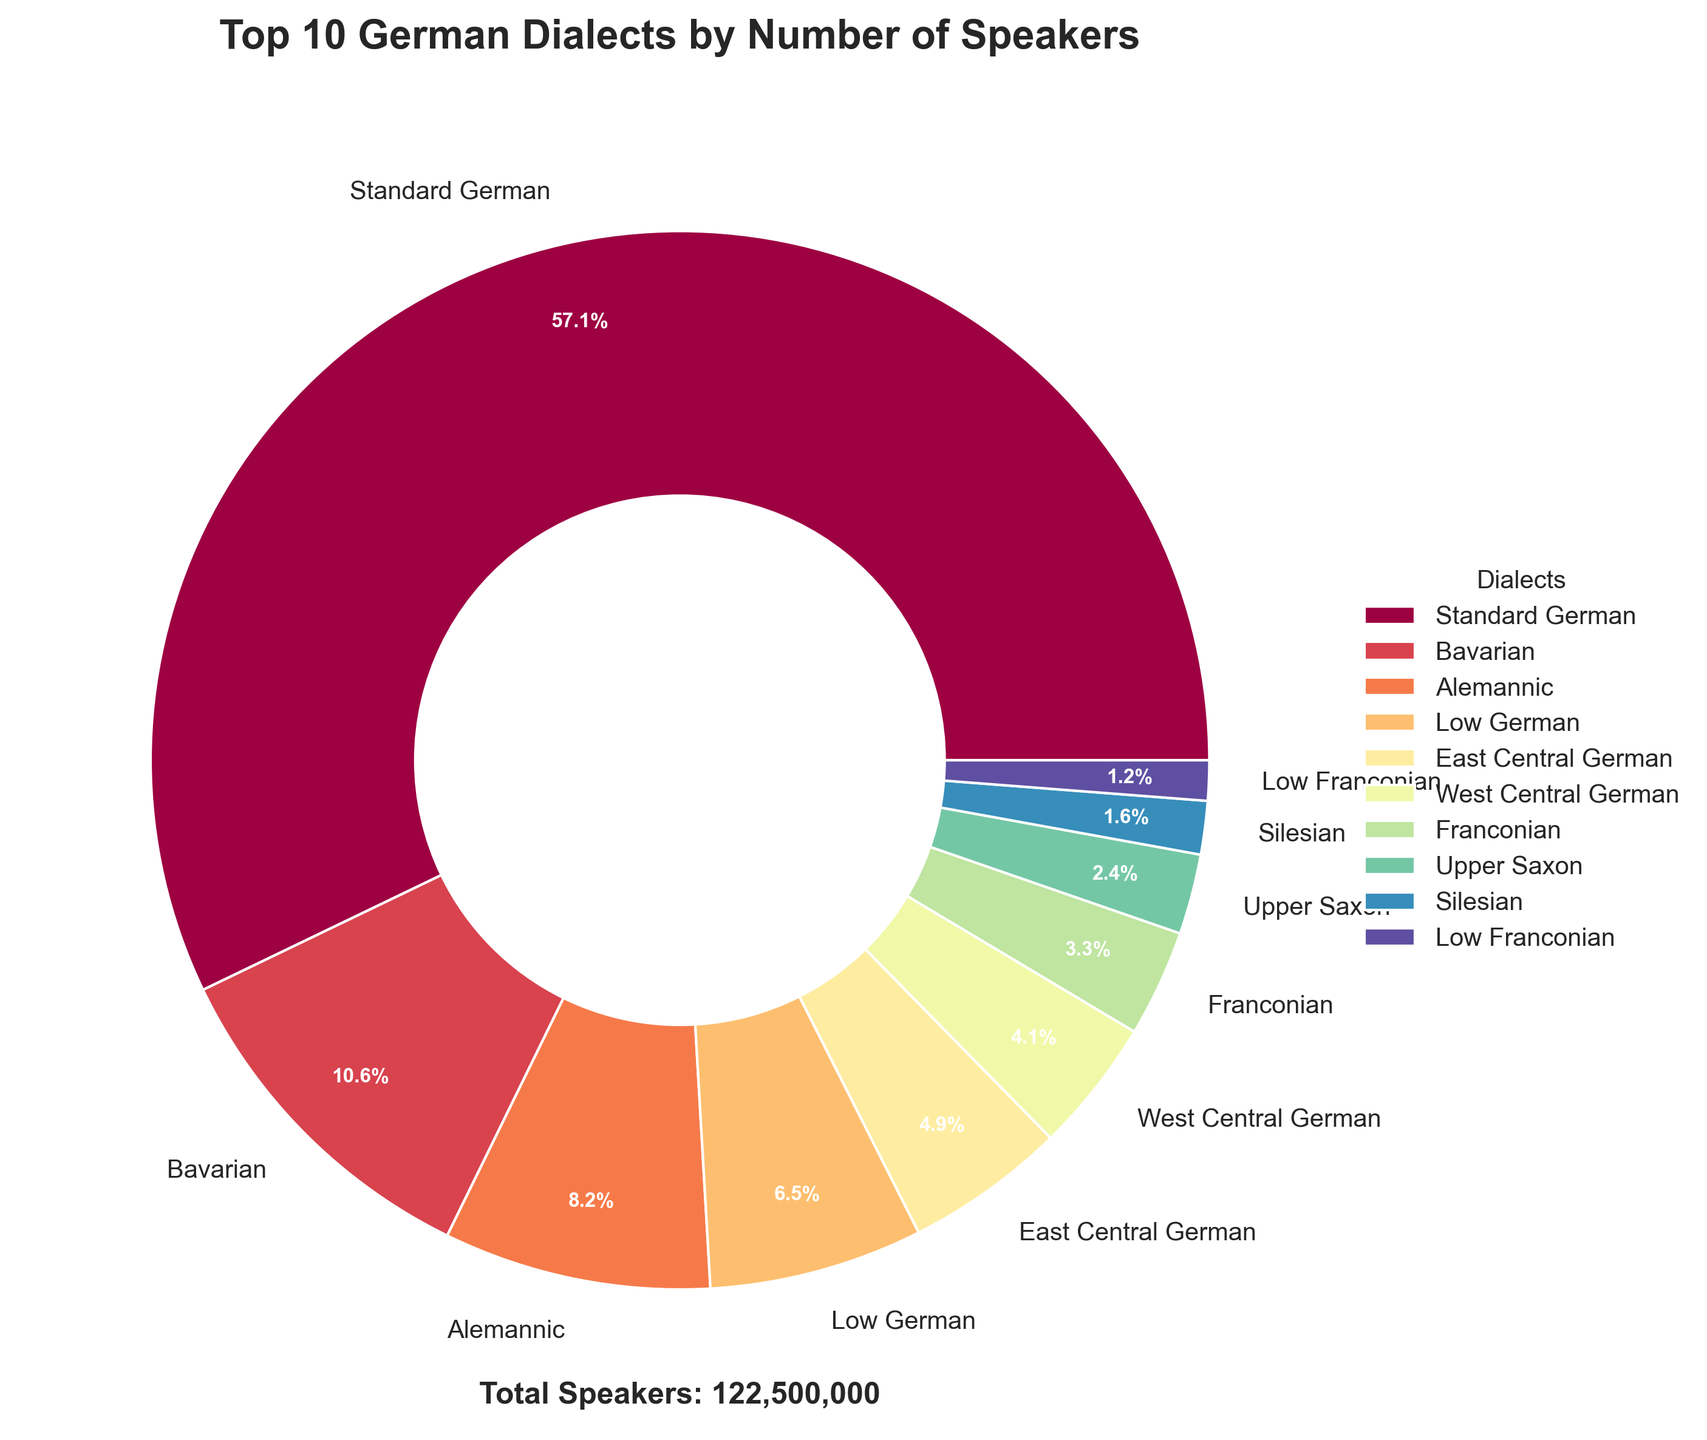Which dialect has the highest number of speakers? The pie chart title mentions "Top 10 German Dialects by Number of Speakers." Among the listed dialects, "Standard German" is the one that occupies the largest portion of the pie chart, indicating it has the highest number of speakers.
Answer: Standard German Which dialects have fewer than 5% of the total speakers among the top 10 dialects? To determine which dialects have less than 5%, we look at the pie chart segments labeled with percentages. Dialects labeled with percentages less than 5% include Upper Saxon, Silesian, East Franconian, and Low Franconian.
Answer: Upper Saxon, Silesian, East Franconian, Low Franconian By how much do the number of speakers of Bavarian exceed those of Low German? According to the pie chart, Bavarian and Low German segments are labeled with their percentages. Bavarian has 13,000,000 speakers and Low German has 8,000,000 speakers. The difference is 13,000,000 - 8,000,000.
Answer: 5,000,000 How many more speakers does Alemannic have compared to Franconian? Alemannic speakers are 10,000,000 and Franconian speakers are 4,000,000. Subtract Franconian from Alemannic to find the difference: 10,000,000 - 4,000,000.
Answer: 6,000,000 What is the combined percentage of speakers for East Central German and West Central German? The pie chart will have labels for each segment representing the percentage of speakers. Combining the percentages for East Central German and West Central German will give the desired value (e.g., percentages from the pie chart might show 8.6% + 5.7%).
Answer: 8.6% + 5.7% Which two dialects have the closest number of speakers? By examining the pie chart, look for the two segments that are visually closest in size. The segments for West Central German and Franconian appear to be closest, indicating they have the most similar speaker numbers.
Answer: West Central German, Franconian What proportion of the total speakers of the top 10 dialects is made up by the Standard German, Bavarian, and Alemannic dialects combined? To find this, add the percentages of Standard German, Bavarian, and Alemannic from the chart (e.g., Standard German might be 70%, Bavarian 13%, Alemannic 10%). The combined total of these percentages is what is required.
Answer: 70% + 13% + 10% How many total speakers are represented in the pie chart? The pie chart includes a text annotation that states the total number of speakers for the top 10 dialects combined. This number is explicitly shown in a text box on the chart.
Answer: 136,000,000 Which dialect represents the smallest slice of the pie chart? Visually inspecting the pie chart, the slice representing the smallest proportion among the top 10 dialects is the least noticeable. This looks like it is the Low Franconian segment.
Answer: Low Franconian 